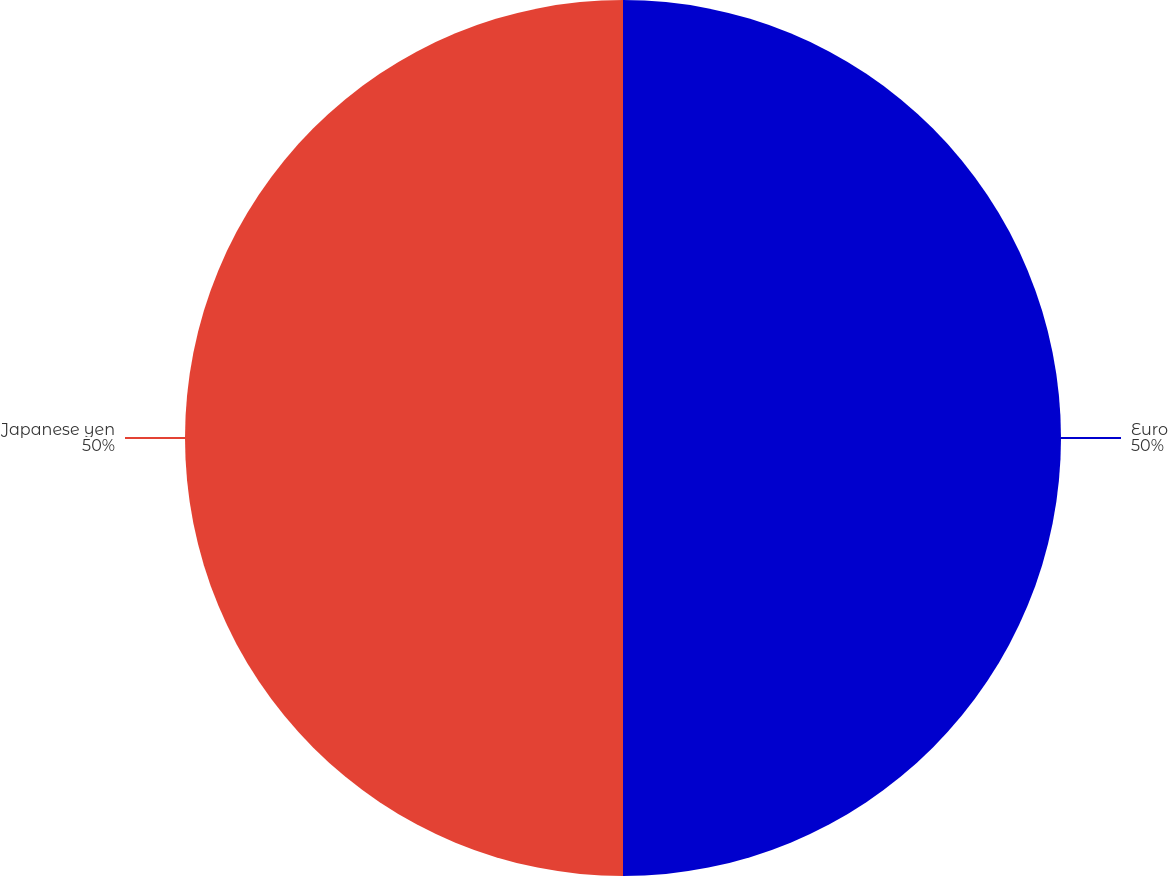<chart> <loc_0><loc_0><loc_500><loc_500><pie_chart><fcel>Euro<fcel>Japanese yen<nl><fcel>50.0%<fcel>50.0%<nl></chart> 